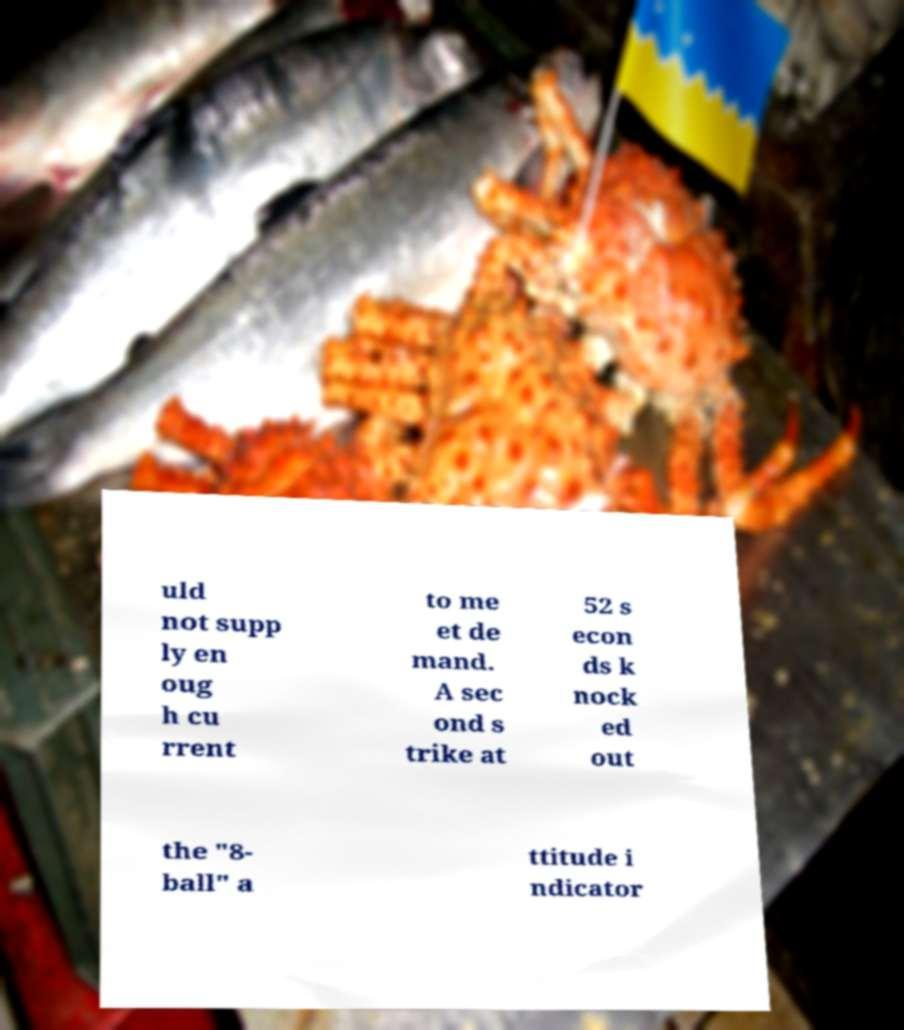Please identify and transcribe the text found in this image. uld not supp ly en oug h cu rrent to me et de mand. A sec ond s trike at 52 s econ ds k nock ed out the "8- ball" a ttitude i ndicator 